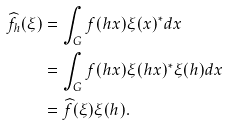<formula> <loc_0><loc_0><loc_500><loc_500>\widehat { f _ { h } } ( \xi ) & = \int _ { G } f ( h x ) \xi ( x ) ^ { * } d x \\ & = \int _ { G } f ( h x ) \xi ( h x ) ^ { * } \xi ( h ) d x \\ & = \widehat { f } ( \xi ) \xi ( h ) .</formula> 